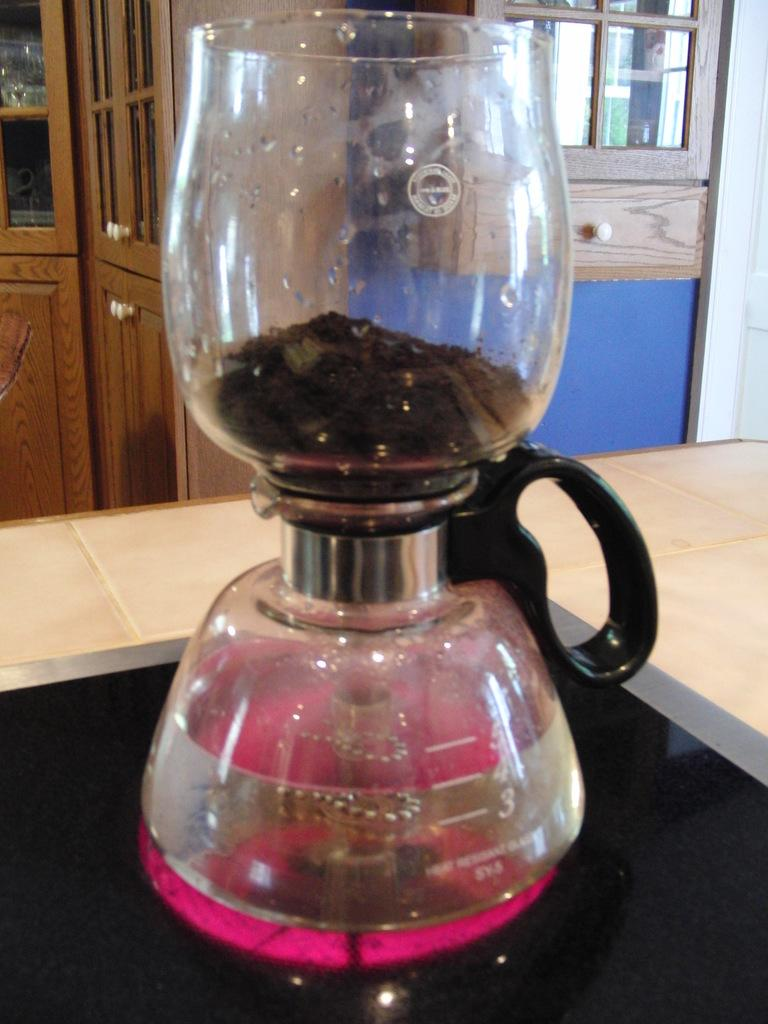<image>
Relay a brief, clear account of the picture shown. A coffee pot in a kitchen with liquid fill up above the number 3 line. 